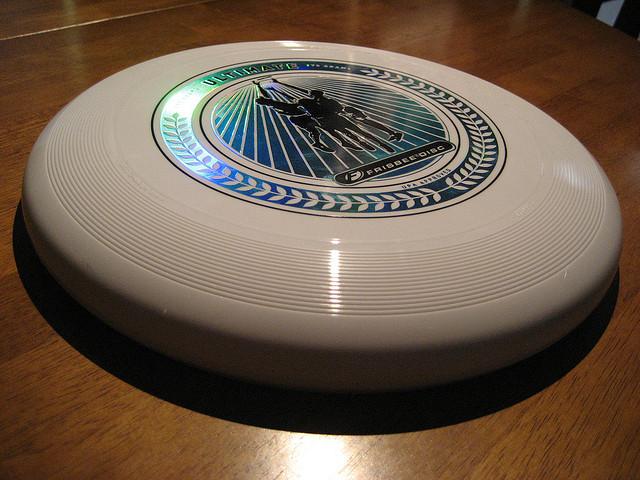What color is the frisbee?
Give a very brief answer. White. What team is this for?
Concise answer only. Frisbee. What activity is this used for?
Be succinct. Frisbee. Is there an image of people on the frisbee?
Keep it brief. Yes. 